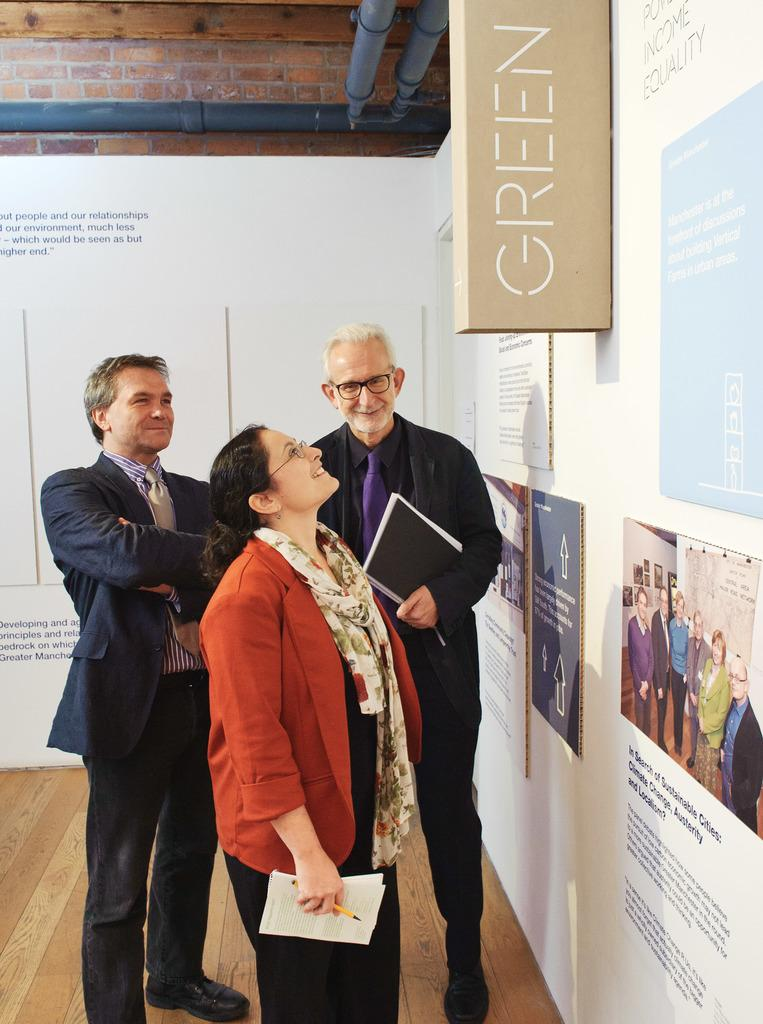What are the people in the image doing? The persons in the center of the image are standing and smiling. What can be seen on the wall in the image? There are boards on the wall with text written on them. What is visible at the top of the image? There are pipes visible at the top of the image. What type of sticks are being smashed by the persons in the image? There are no sticks or smashing actions depicted in the image. Is there a crook present in the image? There is no crook present in the image. 